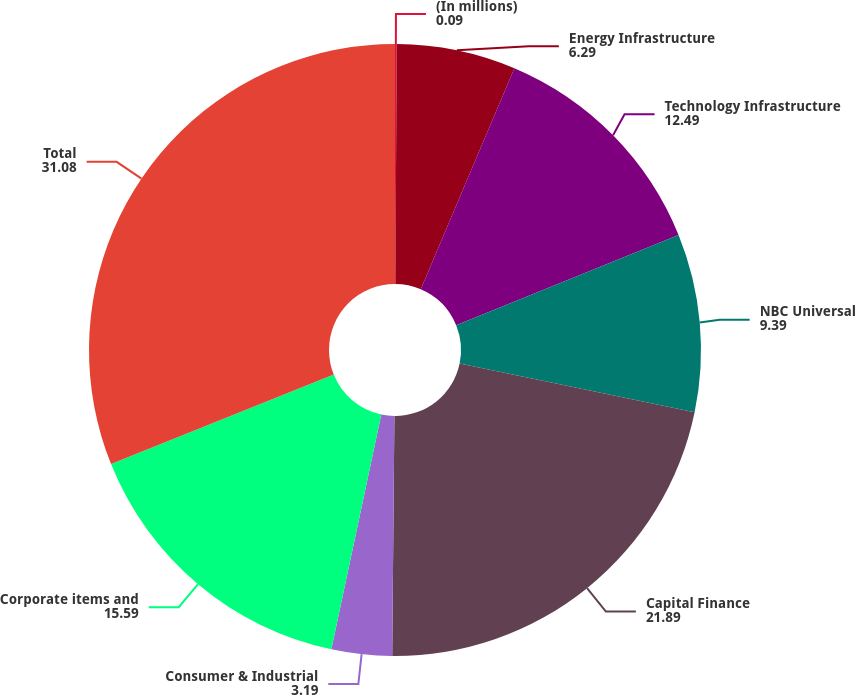Convert chart. <chart><loc_0><loc_0><loc_500><loc_500><pie_chart><fcel>(In millions)<fcel>Energy Infrastructure<fcel>Technology Infrastructure<fcel>NBC Universal<fcel>Capital Finance<fcel>Consumer & Industrial<fcel>Corporate items and<fcel>Total<nl><fcel>0.09%<fcel>6.29%<fcel>12.49%<fcel>9.39%<fcel>21.89%<fcel>3.19%<fcel>15.59%<fcel>31.08%<nl></chart> 